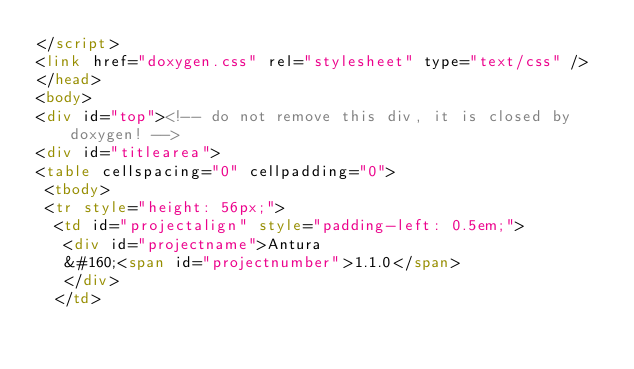<code> <loc_0><loc_0><loc_500><loc_500><_HTML_></script>
<link href="doxygen.css" rel="stylesheet" type="text/css" />
</head>
<body>
<div id="top"><!-- do not remove this div, it is closed by doxygen! -->
<div id="titlearea">
<table cellspacing="0" cellpadding="0">
 <tbody>
 <tr style="height: 56px;">
  <td id="projectalign" style="padding-left: 0.5em;">
   <div id="projectname">Antura
   &#160;<span id="projectnumber">1.1.0</span>
   </div>
  </td></code> 